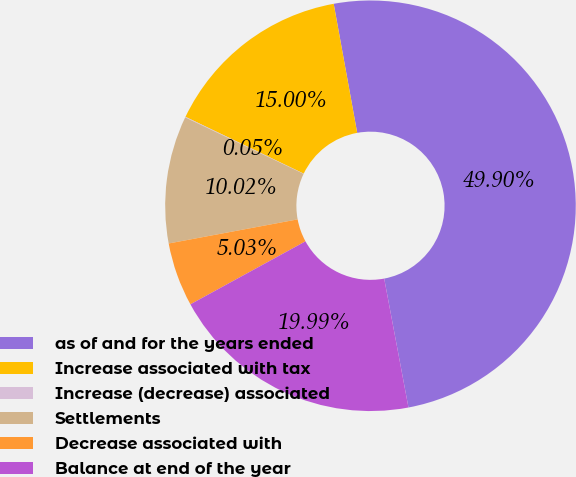<chart> <loc_0><loc_0><loc_500><loc_500><pie_chart><fcel>as of and for the years ended<fcel>Increase associated with tax<fcel>Increase (decrease) associated<fcel>Settlements<fcel>Decrease associated with<fcel>Balance at end of the year<nl><fcel>49.9%<fcel>15.0%<fcel>0.05%<fcel>10.02%<fcel>5.03%<fcel>19.99%<nl></chart> 